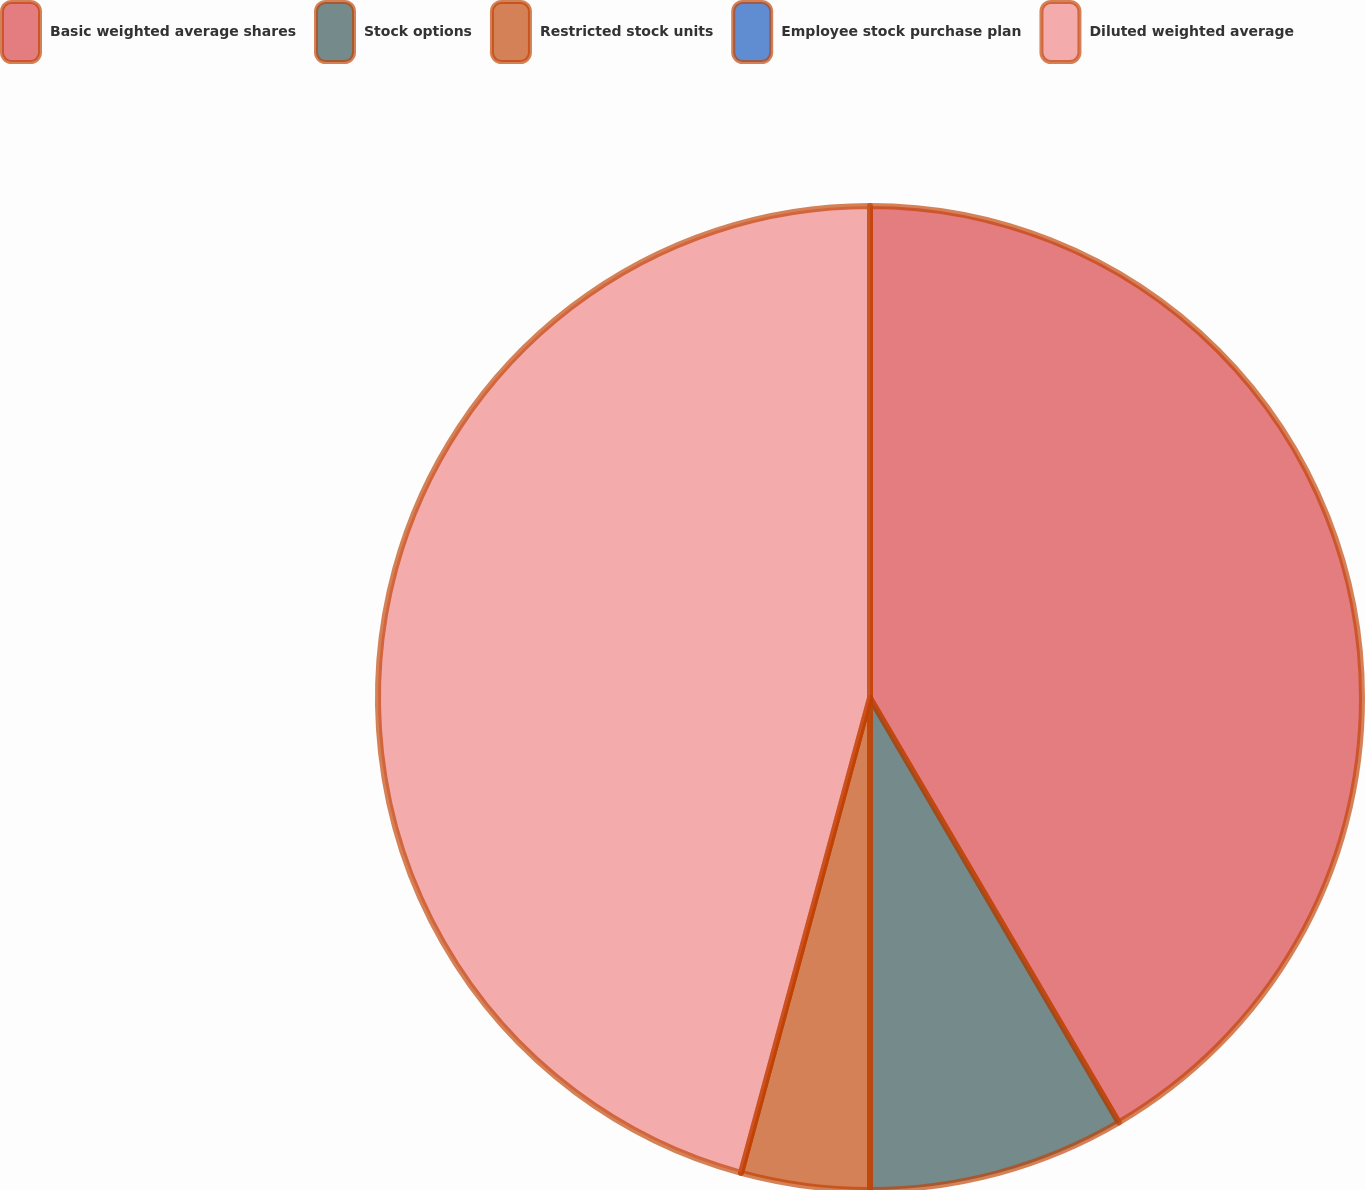Convert chart to OTSL. <chart><loc_0><loc_0><loc_500><loc_500><pie_chart><fcel>Basic weighted average shares<fcel>Stock options<fcel>Restricted stock units<fcel>Employee stock purchase plan<fcel>Diluted weighted average<nl><fcel>41.56%<fcel>8.44%<fcel>4.22%<fcel>0.0%<fcel>45.78%<nl></chart> 